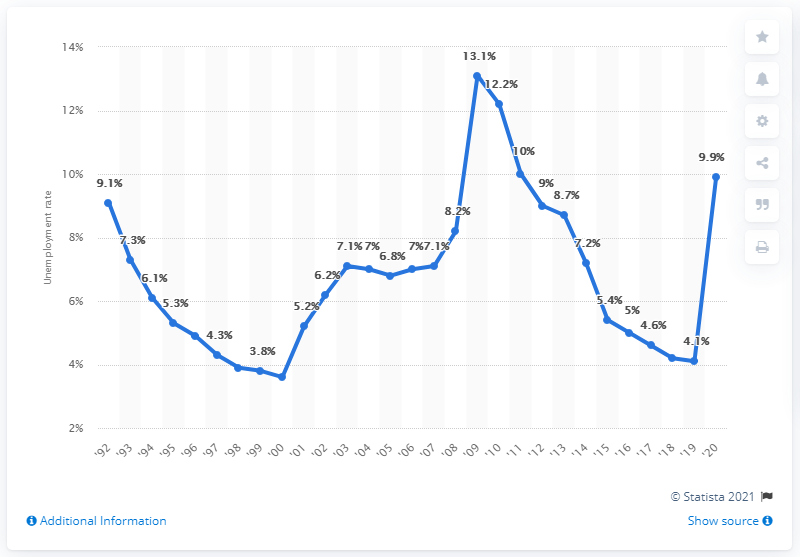Highlight a few significant elements in this photo. In 2009, the unemployment rate in the state of Michigan was 4.1%. In 2020, Michigan's unemployment rate was 9.9%. 